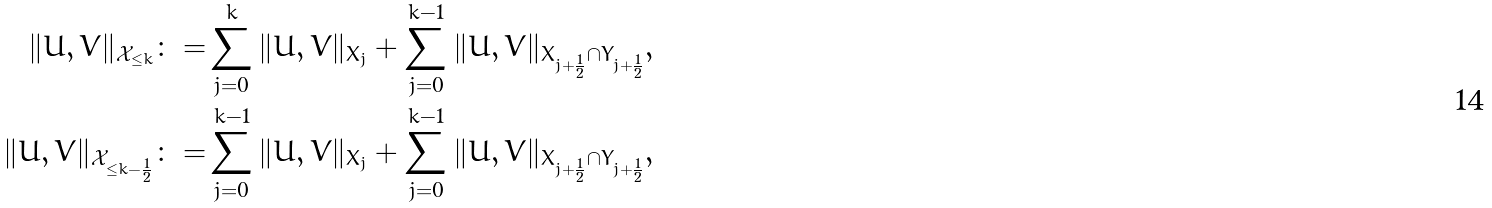<formula> <loc_0><loc_0><loc_500><loc_500>\| U , V \| _ { \mathcal { X } _ { \leq k } } \colon = & \sum _ { j = 0 } ^ { k } \| U , V \| _ { X _ { j } } + \sum _ { j = 0 } ^ { k - 1 } \| U , V \| _ { X _ { j + \frac { 1 } { 2 } } \cap Y _ { j + \frac { 1 } { 2 } } } , \\ \| U , V \| _ { \mathcal { X } _ { \leq k - \frac { 1 } { 2 } } } \colon = & \sum _ { j = 0 } ^ { k - 1 } \| U , V \| _ { X _ { j } } + \sum _ { j = 0 } ^ { k - 1 } \| U , V \| _ { X _ { j + \frac { 1 } { 2 } } \cap Y _ { j + \frac { 1 } { 2 } } } ,</formula> 